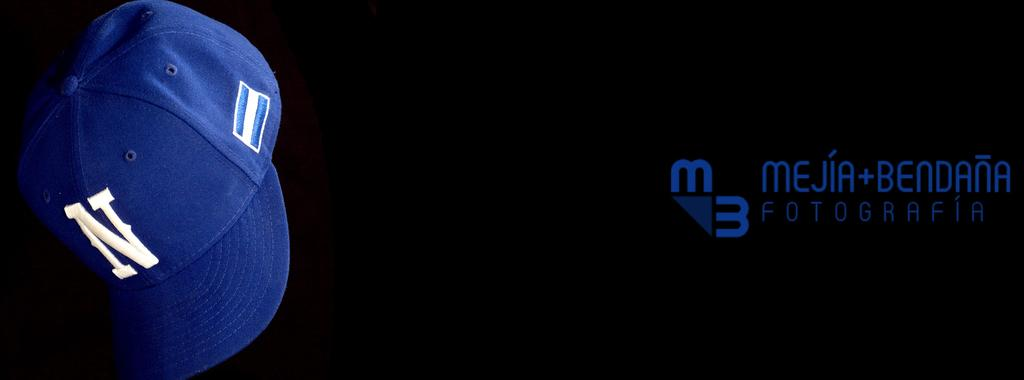What object is located on the left side of the image? There is a cap on the left side of the image. What color is the cap? The cap is blue. What can be seen on the right side of the image? There is text written on the right side of the image. What is the color of the background in the image? The background of the image is black. What advice does the uncle give in the image? There is no uncle present in the image, nor is there any advice being given. 